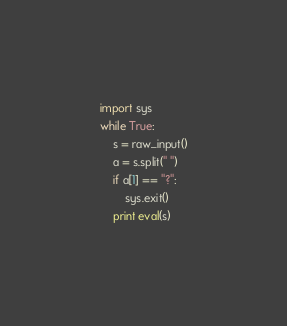Convert code to text. <code><loc_0><loc_0><loc_500><loc_500><_Python_>import sys
while True:
    s = raw_input()
    a = s.split(" ")
    if a[1] == "?":
        sys.exit()
    print eval(s)</code> 